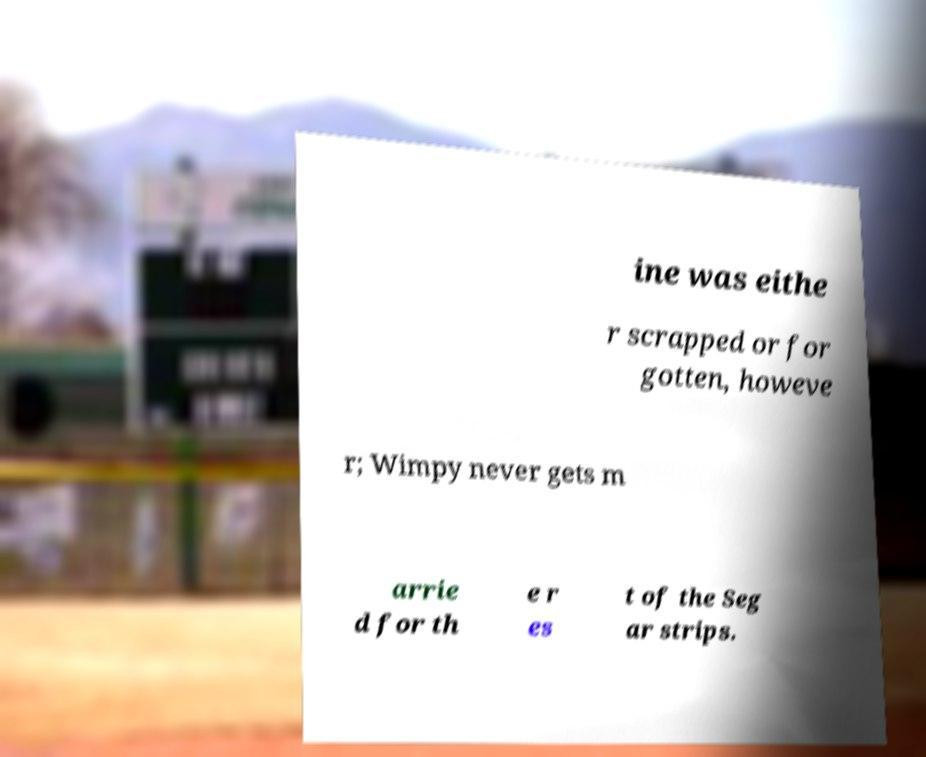I need the written content from this picture converted into text. Can you do that? ine was eithe r scrapped or for gotten, howeve r; Wimpy never gets m arrie d for th e r es t of the Seg ar strips. 